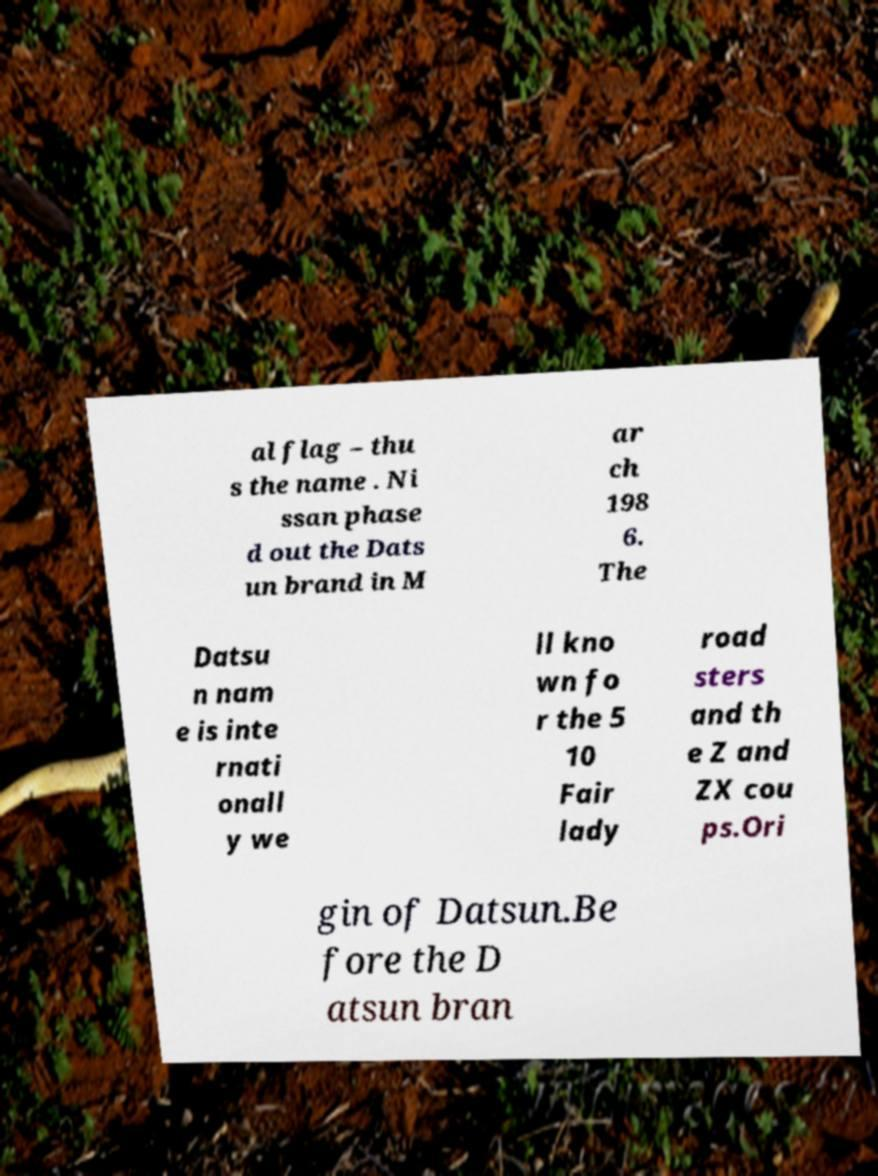For documentation purposes, I need the text within this image transcribed. Could you provide that? al flag – thu s the name . Ni ssan phase d out the Dats un brand in M ar ch 198 6. The Datsu n nam e is inte rnati onall y we ll kno wn fo r the 5 10 Fair lady road sters and th e Z and ZX cou ps.Ori gin of Datsun.Be fore the D atsun bran 